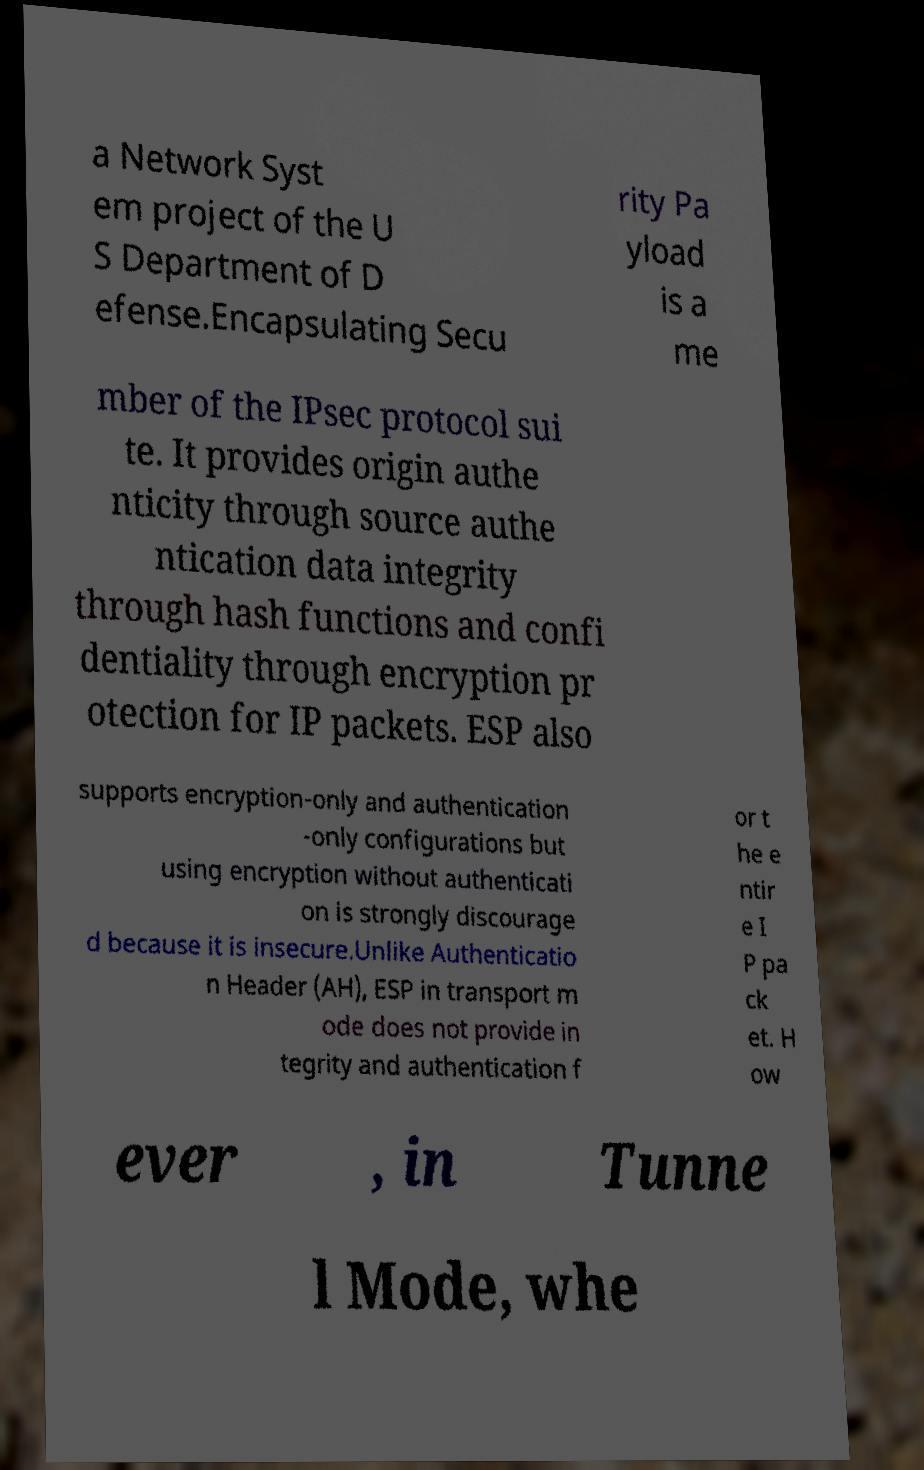Can you accurately transcribe the text from the provided image for me? a Network Syst em project of the U S Department of D efense.Encapsulating Secu rity Pa yload is a me mber of the IPsec protocol sui te. It provides origin authe nticity through source authe ntication data integrity through hash functions and confi dentiality through encryption pr otection for IP packets. ESP also supports encryption-only and authentication -only configurations but using encryption without authenticati on is strongly discourage d because it is insecure.Unlike Authenticatio n Header (AH), ESP in transport m ode does not provide in tegrity and authentication f or t he e ntir e I P pa ck et. H ow ever , in Tunne l Mode, whe 